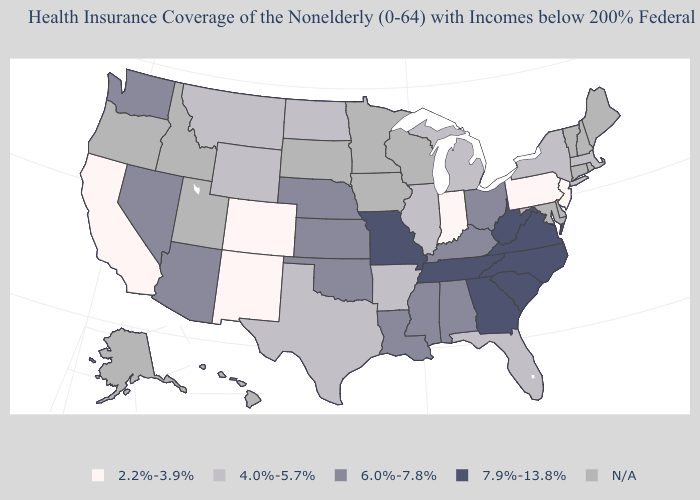Which states have the highest value in the USA?
Quick response, please. Georgia, Missouri, North Carolina, South Carolina, Tennessee, Virginia, West Virginia. Which states have the lowest value in the USA?
Short answer required. California, Colorado, Indiana, New Jersey, New Mexico, Pennsylvania. What is the highest value in the USA?
Concise answer only. 7.9%-13.8%. What is the highest value in the USA?
Concise answer only. 7.9%-13.8%. What is the value of Illinois?
Quick response, please. 4.0%-5.7%. What is the value of Delaware?
Be succinct. N/A. Does Missouri have the lowest value in the MidWest?
Answer briefly. No. Does New Jersey have the highest value in the Northeast?
Answer briefly. No. Name the states that have a value in the range 4.0%-5.7%?
Write a very short answer. Arkansas, Florida, Illinois, Massachusetts, Michigan, Montana, New York, North Dakota, Texas, Wyoming. What is the value of Kansas?
Concise answer only. 6.0%-7.8%. Name the states that have a value in the range 7.9%-13.8%?
Write a very short answer. Georgia, Missouri, North Carolina, South Carolina, Tennessee, Virginia, West Virginia. Name the states that have a value in the range N/A?
Answer briefly. Alaska, Connecticut, Delaware, Hawaii, Idaho, Iowa, Maine, Maryland, Minnesota, New Hampshire, Oregon, Rhode Island, South Dakota, Utah, Vermont, Wisconsin. Does Alabama have the lowest value in the USA?
Write a very short answer. No. Does the first symbol in the legend represent the smallest category?
Be succinct. Yes. 